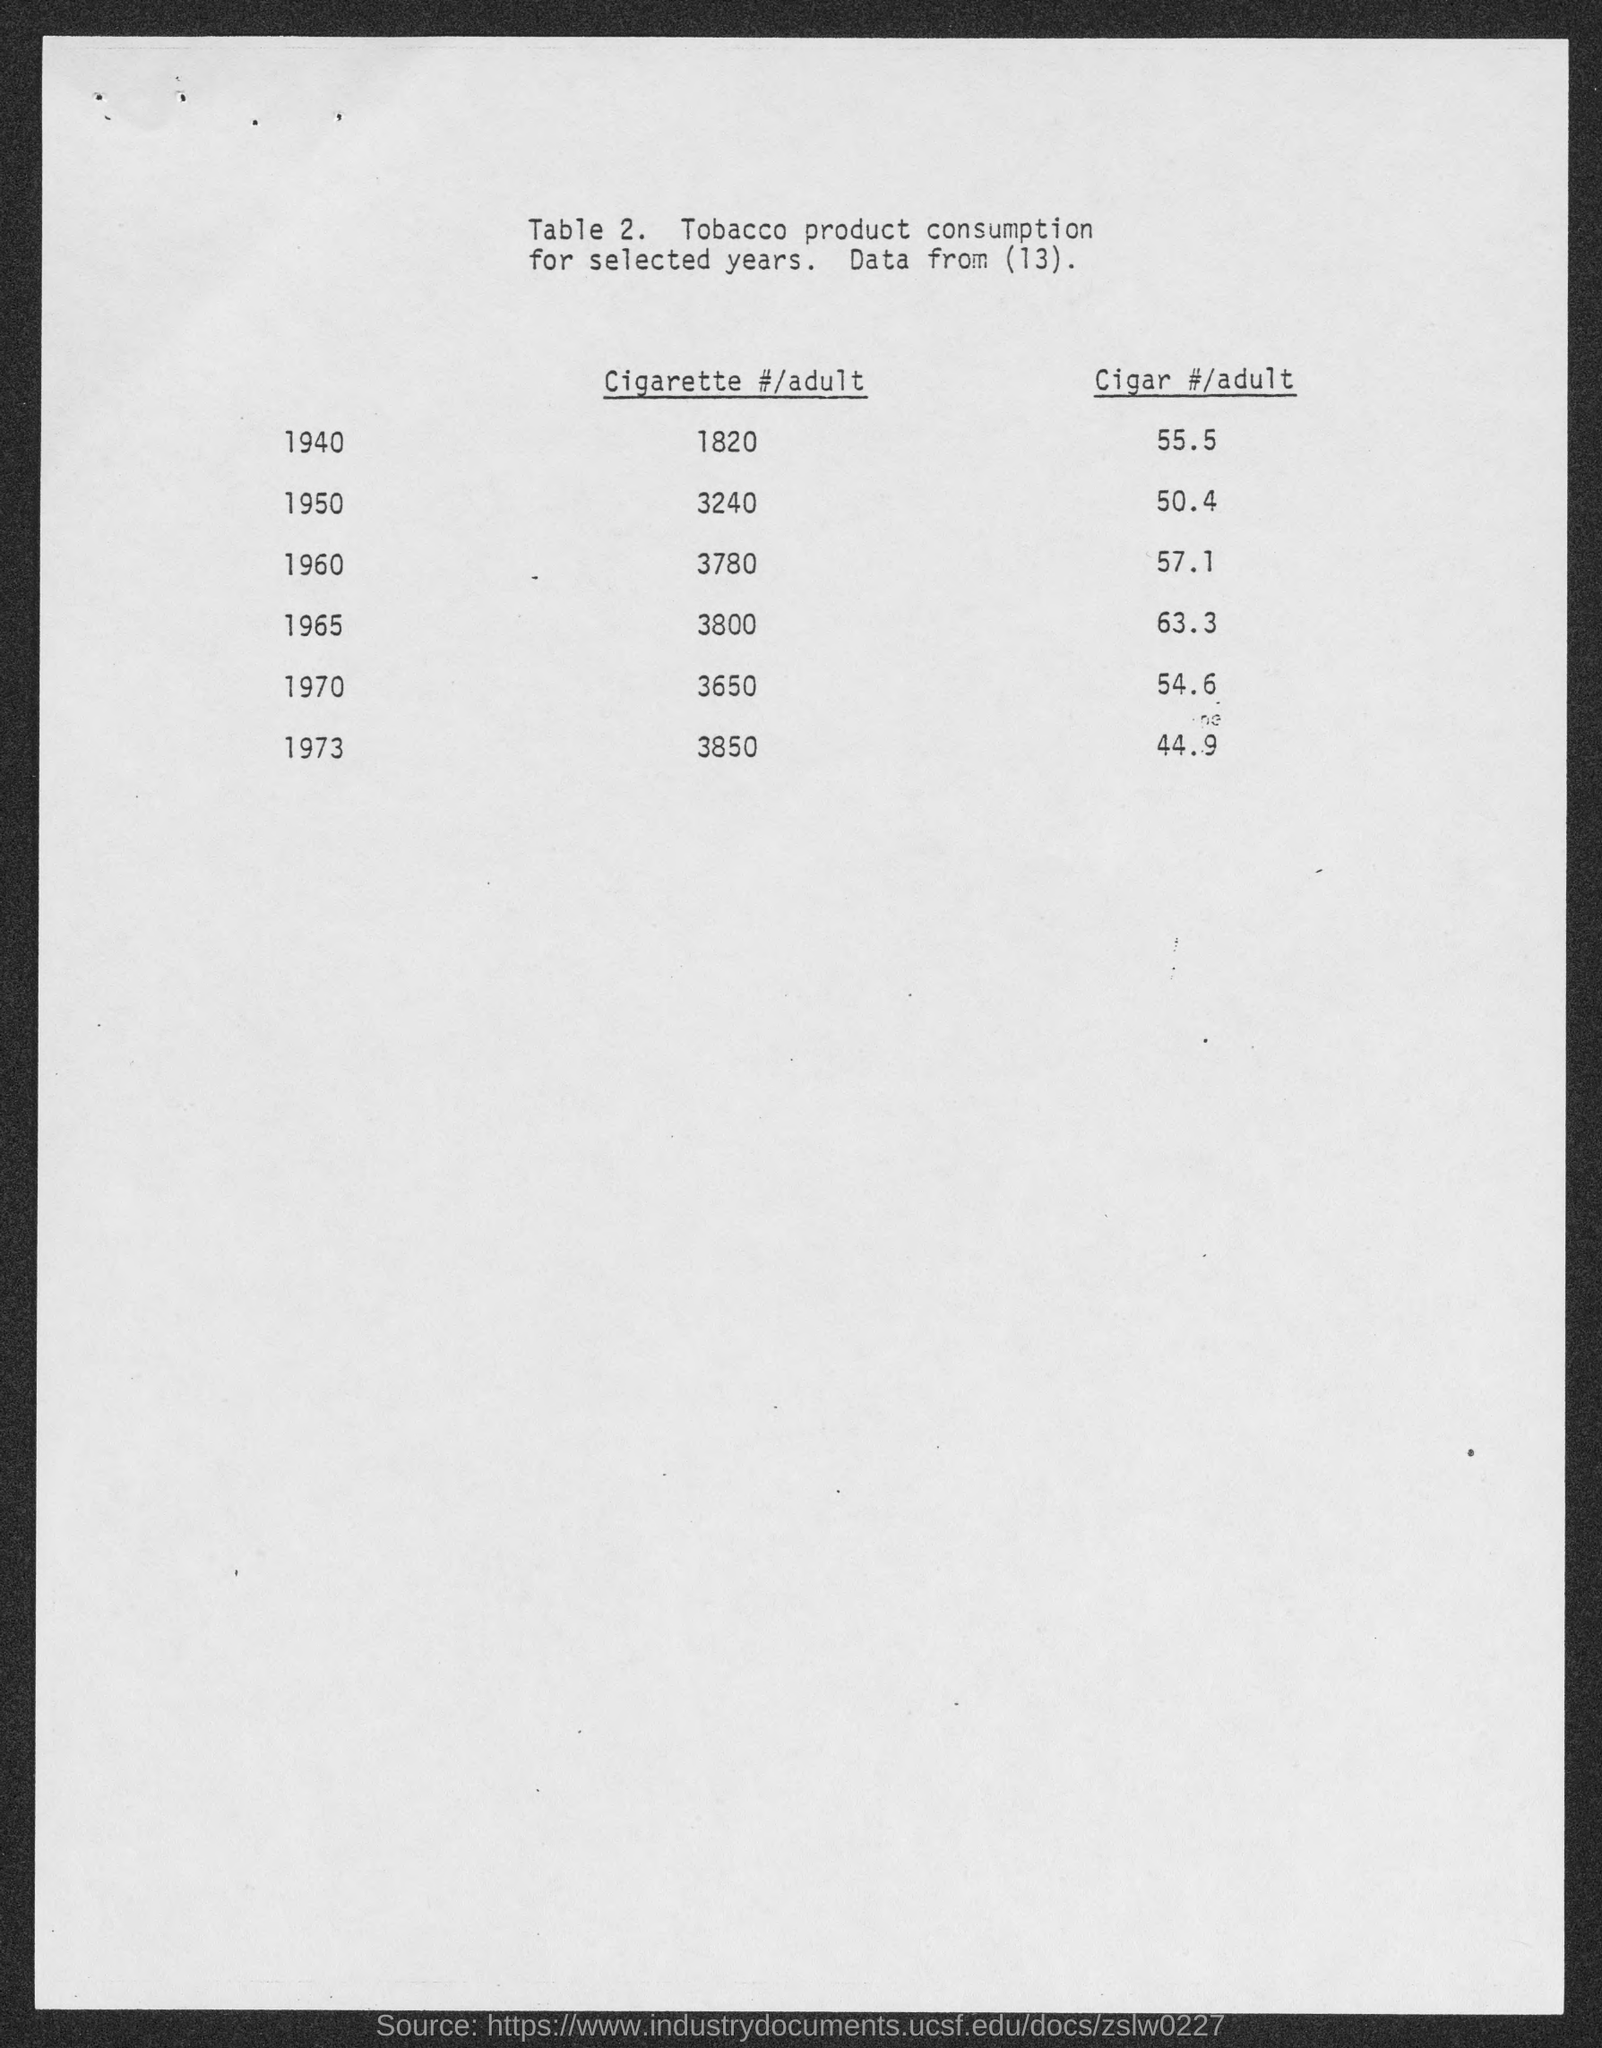What is the table no.?
Your answer should be compact. 2. 